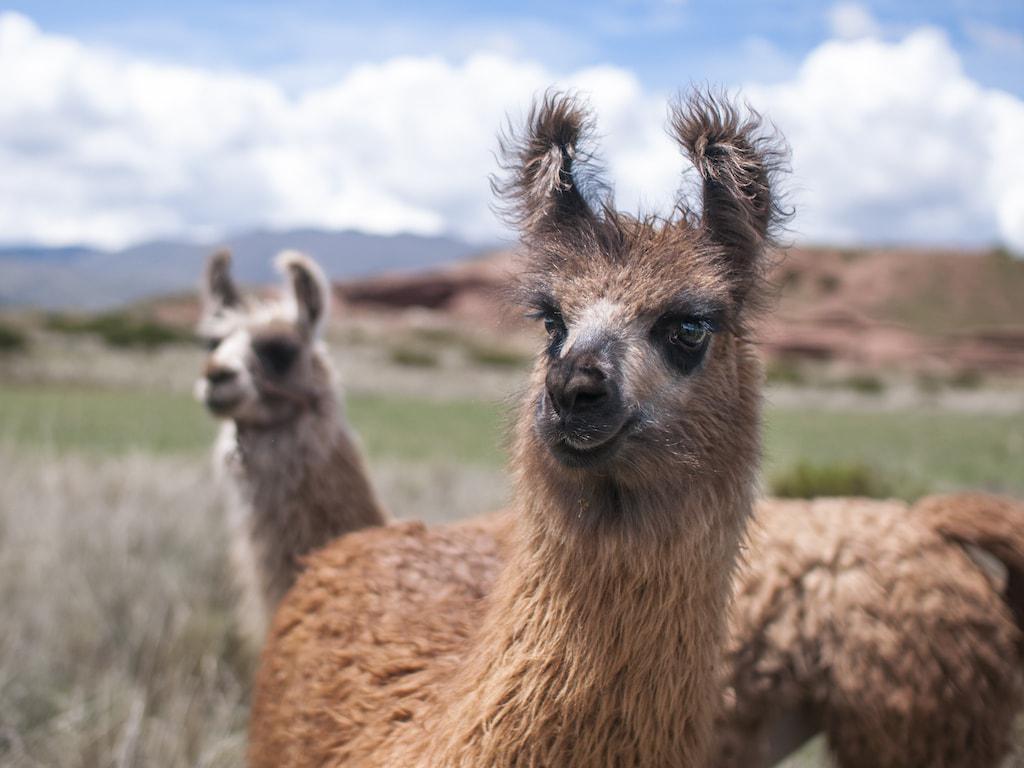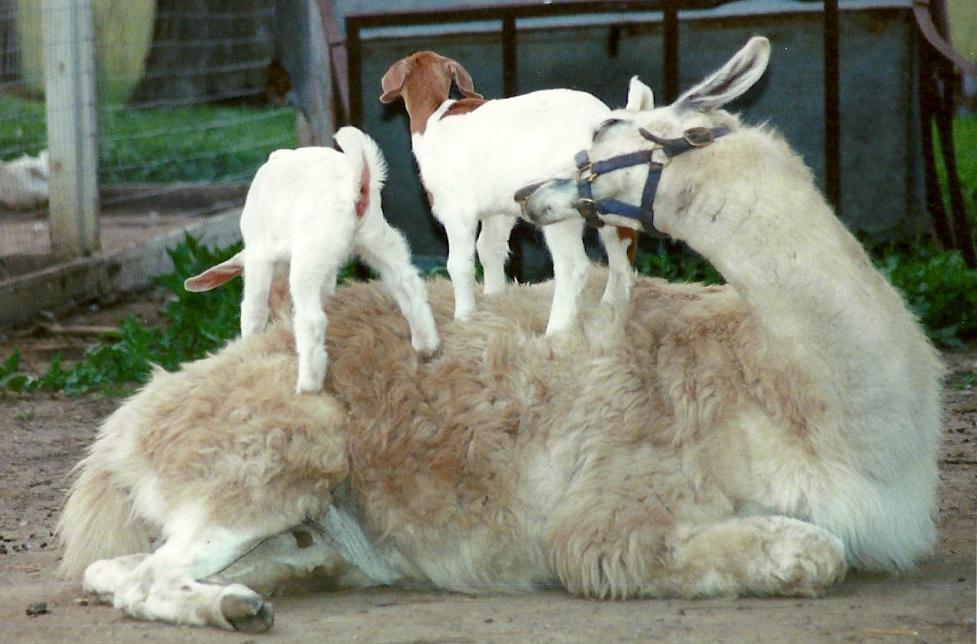The first image is the image on the left, the second image is the image on the right. Evaluate the accuracy of this statement regarding the images: "There are two llamas in the left image and one llama in the right image.". Is it true? Answer yes or no. Yes. The first image is the image on the left, the second image is the image on the right. Analyze the images presented: Is the assertion "Each llama in the pair of images is an adult llama." valid? Answer yes or no. No. 